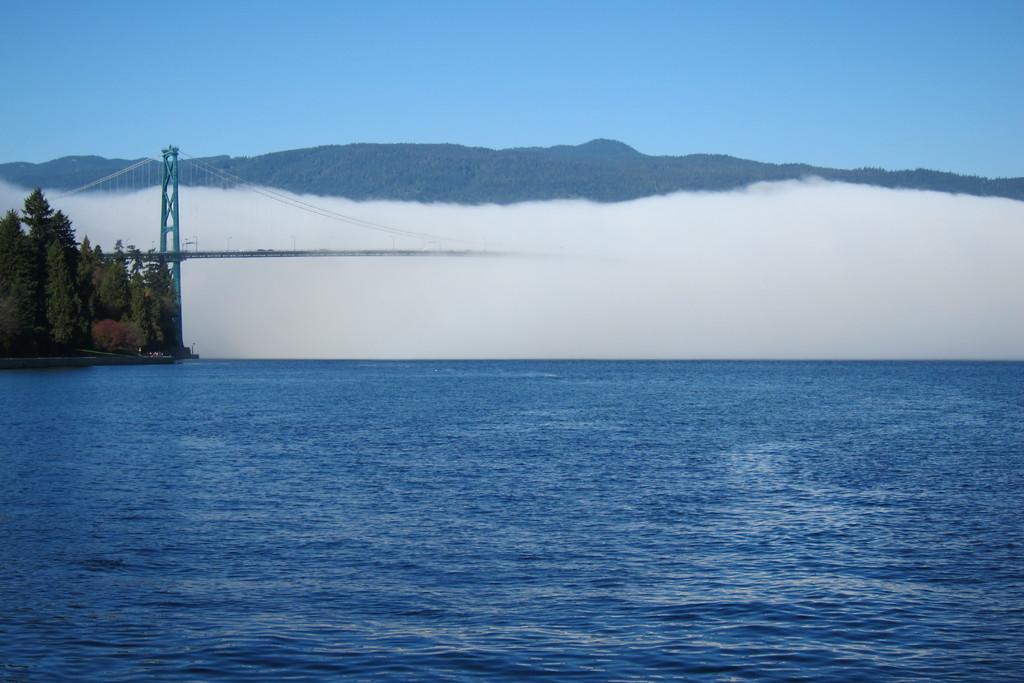What is the main feature in the front of the image? There is an ocean in the front of the image. What can be seen in the background of the image? There are trees, a bridge, and mountains in the background of the image. What type of pest can be seen crawling on the bridge in the image? There are no pests visible in the image, and the bridge is not the main focus of the conversation. 